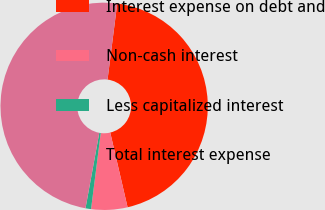Convert chart to OTSL. <chart><loc_0><loc_0><loc_500><loc_500><pie_chart><fcel>Interest expense on debt and<fcel>Non-cash interest<fcel>Less capitalized interest<fcel>Total interest expense<nl><fcel>44.35%<fcel>5.65%<fcel>0.86%<fcel>49.14%<nl></chart> 